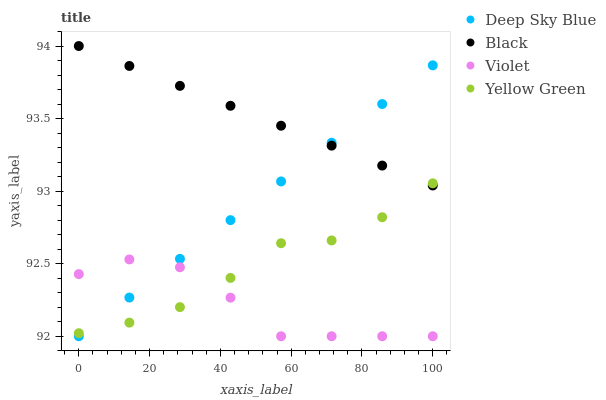Does Violet have the minimum area under the curve?
Answer yes or no. Yes. Does Black have the maximum area under the curve?
Answer yes or no. Yes. Does Yellow Green have the minimum area under the curve?
Answer yes or no. No. Does Yellow Green have the maximum area under the curve?
Answer yes or no. No. Is Deep Sky Blue the smoothest?
Answer yes or no. Yes. Is Violet the roughest?
Answer yes or no. Yes. Is Yellow Green the smoothest?
Answer yes or no. No. Is Yellow Green the roughest?
Answer yes or no. No. Does Deep Sky Blue have the lowest value?
Answer yes or no. Yes. Does Yellow Green have the lowest value?
Answer yes or no. No. Does Black have the highest value?
Answer yes or no. Yes. Does Yellow Green have the highest value?
Answer yes or no. No. Is Violet less than Black?
Answer yes or no. Yes. Is Black greater than Violet?
Answer yes or no. Yes. Does Deep Sky Blue intersect Violet?
Answer yes or no. Yes. Is Deep Sky Blue less than Violet?
Answer yes or no. No. Is Deep Sky Blue greater than Violet?
Answer yes or no. No. Does Violet intersect Black?
Answer yes or no. No. 